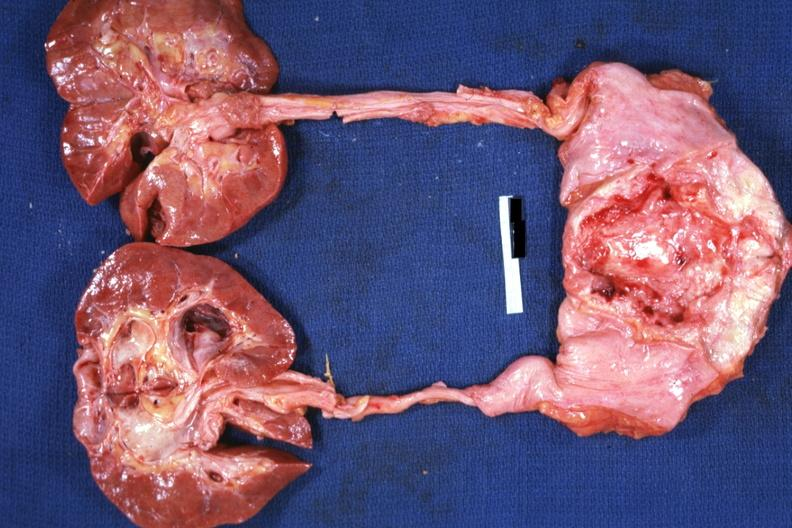s adenocarcinoma present?
Answer the question using a single word or phrase. Yes 